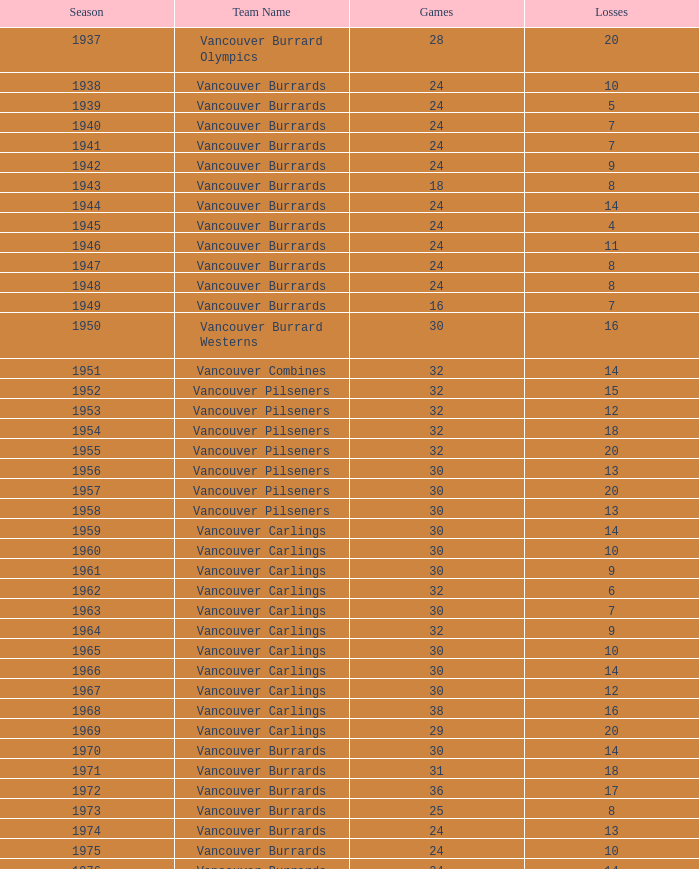What is the lowest point total for the vancouver burrards with under 8 losses and less than 24 games? 18.0. 